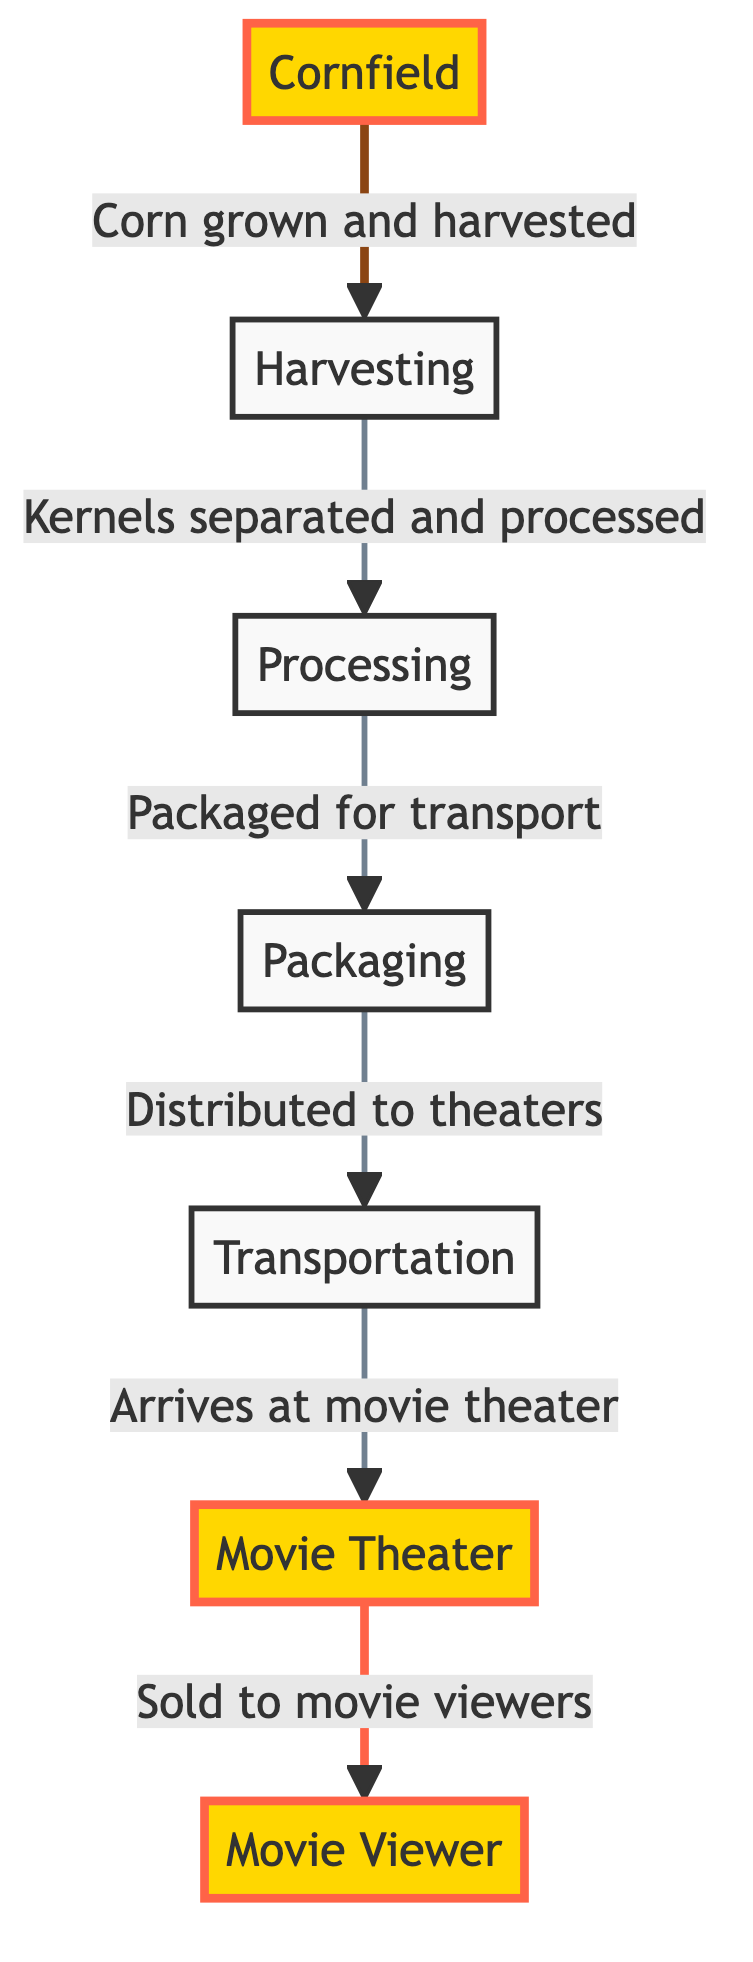What is the first step in the popcorn supply chain? The first step in the popcorn supply chain is represented as the node labeled "Cornfield". This is where the corn is grown before it is harvested.
Answer: Cornfield How many main nodes are in the diagram? By counting each distinct node in the flowchart, we see there are a total of seven main nodes: Cornfield, Harvesting, Processing, Packaging, Transportation, Movie Theater, and Movie Viewer.
Answer: 7 What action happens after packaging? The action that follows packaging, as shown in the diagram flow, is distribution to theaters, denoted by the node labeled "Transportation".
Answer: Transportation Who are the final recipients in the food supply chain? The last node in the chain names the recipients as "Movie Viewer", indicating that they are the consumers of the popcorn sold in movie theaters.
Answer: Movie Viewer What is the relationship between harvesting and processing? The relationship is described as a sequential action where harvested corn is transformed into processed kernels. This is indicated by the directed arrow from the "Harvesting" node to the "Processing" node.
Answer: Kernels separated and processed Which step involves the transportation of popcorn? The step involving transportation is explicitly labeled as "Transportation" in the diagram, connecting the processing stage to the movie theater stage.
Answer: Transportation How many processes are there between the cornfield and the movie viewer? By reviewing the flow from the cornfield to the movie viewer, we identify five processes: Harvesting, Processing, Packaging, Transportation, and Movie Theater.
Answer: 5 What is the significance of the highlighted nodes? The highlighted nodes represent key points in the chain: the starting point "Cornfield" and the endpoint "Movie Theater" and "Movie Viewer", emphasizing the origin and destination of the popcorn supply chain.
Answer: Origin and destination What happens at the movie theater according to the chain? At the movie theater, the popcorn is sold to the movie viewers, which is indicated by the directed link from the "Movie Theater" node to the "Movie Viewer" node.
Answer: Sold to movie viewers 